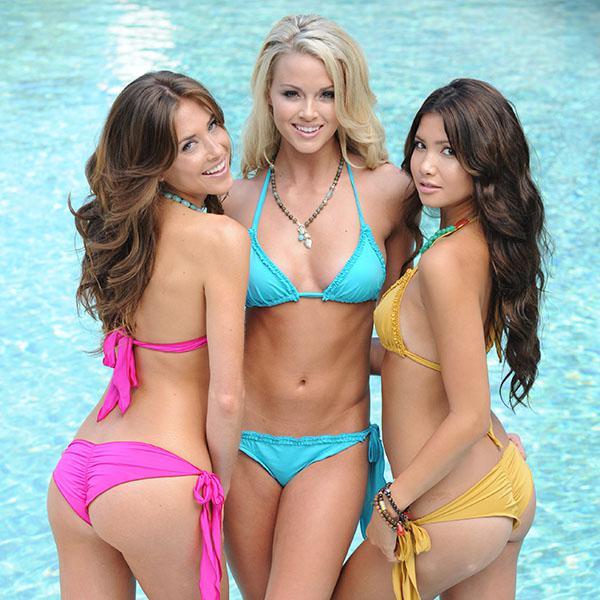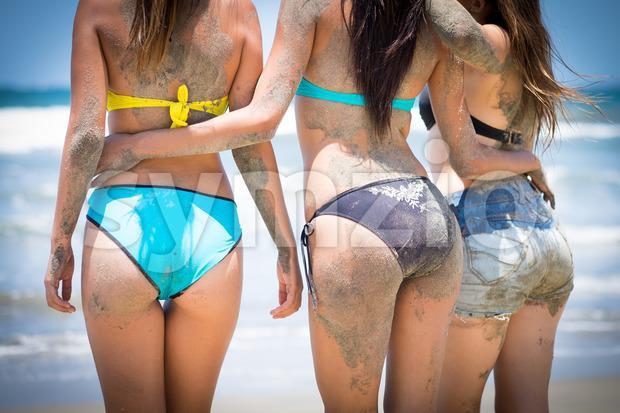The first image is the image on the left, the second image is the image on the right. Assess this claim about the two images: "Three women have their backs at the camera.". Correct or not? Answer yes or no. Yes. The first image is the image on the left, the second image is the image on the right. Evaluate the accuracy of this statement regarding the images: "Three models pose with rears turned to the camera in one image.". Is it true? Answer yes or no. Yes. 